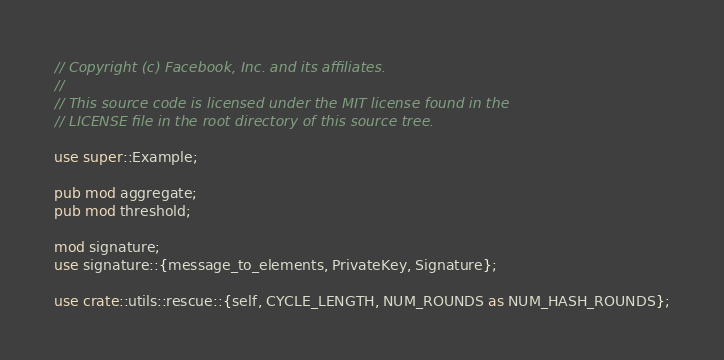Convert code to text. <code><loc_0><loc_0><loc_500><loc_500><_Rust_>// Copyright (c) Facebook, Inc. and its affiliates.
//
// This source code is licensed under the MIT license found in the
// LICENSE file in the root directory of this source tree.

use super::Example;

pub mod aggregate;
pub mod threshold;

mod signature;
use signature::{message_to_elements, PrivateKey, Signature};

use crate::utils::rescue::{self, CYCLE_LENGTH, NUM_ROUNDS as NUM_HASH_ROUNDS};
</code> 